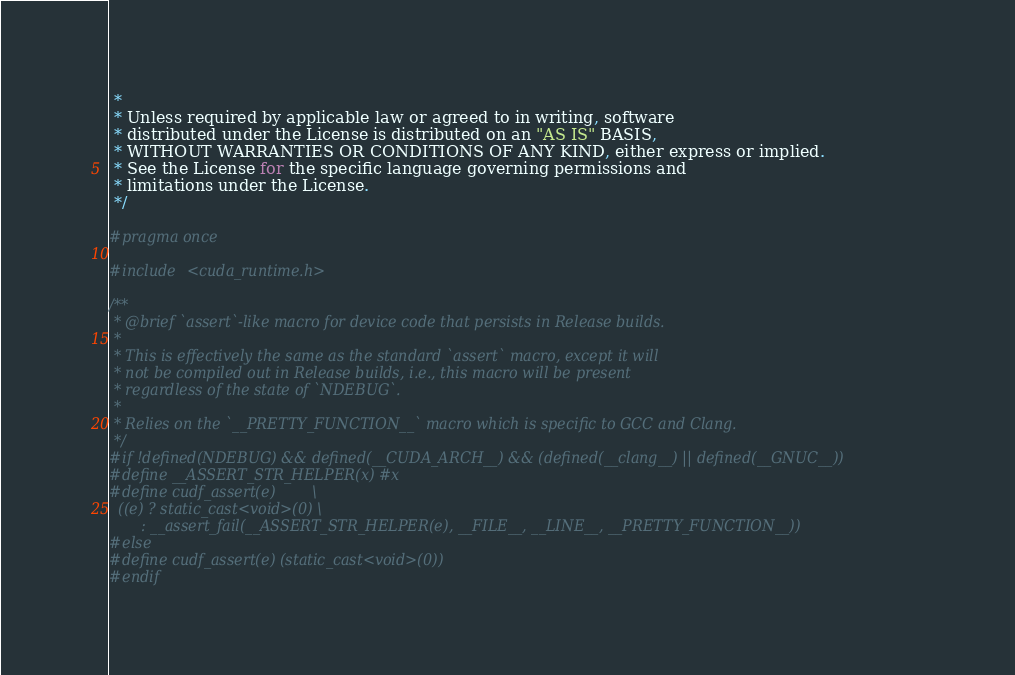Convert code to text. <code><loc_0><loc_0><loc_500><loc_500><_Cuda_> *
 * Unless required by applicable law or agreed to in writing, software
 * distributed under the License is distributed on an "AS IS" BASIS,
 * WITHOUT WARRANTIES OR CONDITIONS OF ANY KIND, either express or implied.
 * See the License for the specific language governing permissions and
 * limitations under the License.
 */

#pragma once

#include <cuda_runtime.h>

/**
 * @brief `assert`-like macro for device code that persists in Release builds.
 *
 * This is effectively the same as the standard `assert` macro, except it will
 * not be compiled out in Release builds, i.e., this macro will be present
 * regardless of the state of `NDEBUG`.
 *
 * Relies on the `__PRETTY_FUNCTION__` macro which is specific to GCC and Clang.
 */
#if !defined(NDEBUG) && defined(__CUDA_ARCH__) && (defined(__clang__) || defined(__GNUC__))
#define __ASSERT_STR_HELPER(x) #x
#define cudf_assert(e)        \
  ((e) ? static_cast<void>(0) \
       : __assert_fail(__ASSERT_STR_HELPER(e), __FILE__, __LINE__, __PRETTY_FUNCTION__))
#else
#define cudf_assert(e) (static_cast<void>(0))
#endif
</code> 